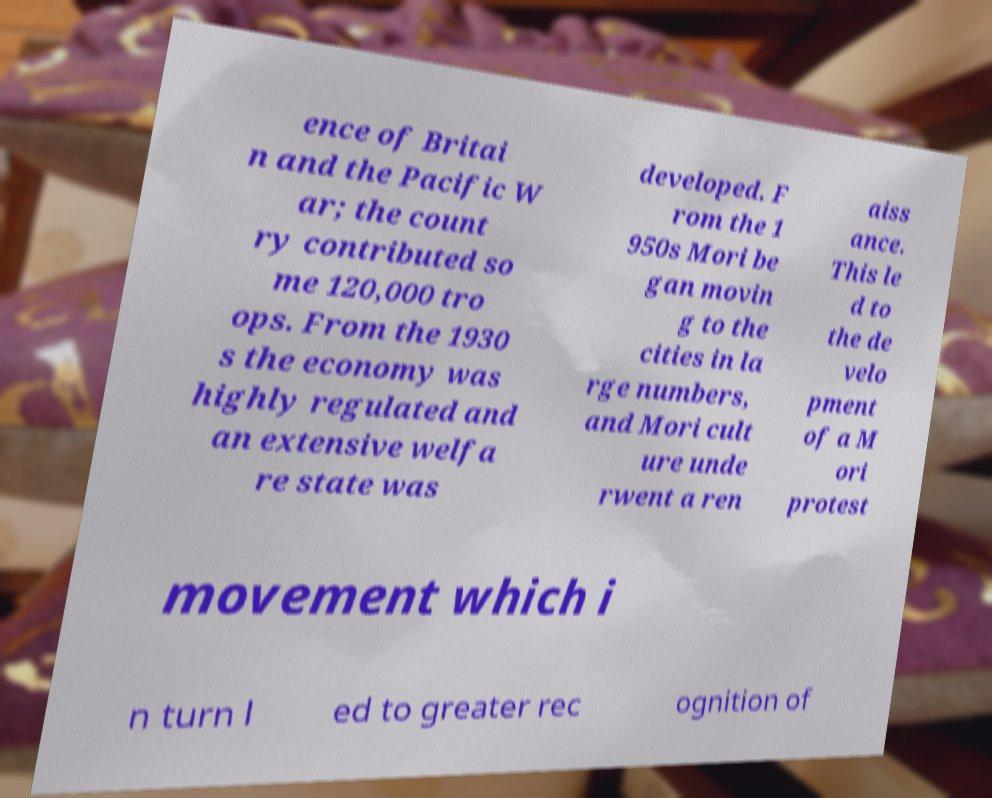Can you read and provide the text displayed in the image?This photo seems to have some interesting text. Can you extract and type it out for me? ence of Britai n and the Pacific W ar; the count ry contributed so me 120,000 tro ops. From the 1930 s the economy was highly regulated and an extensive welfa re state was developed. F rom the 1 950s Mori be gan movin g to the cities in la rge numbers, and Mori cult ure unde rwent a ren aiss ance. This le d to the de velo pment of a M ori protest movement which i n turn l ed to greater rec ognition of 